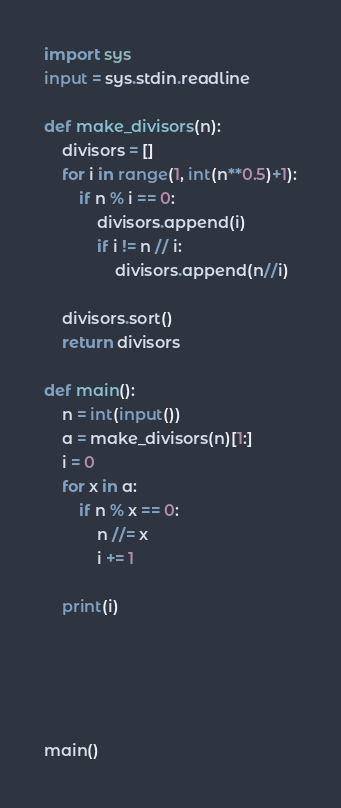<code> <loc_0><loc_0><loc_500><loc_500><_Python_>import sys
input = sys.stdin.readline

def make_divisors(n):
    divisors = []
    for i in range(1, int(n**0.5)+1):
        if n % i == 0:
            divisors.append(i)
            if i != n // i:
                divisors.append(n//i)

    divisors.sort()
    return divisors

def main():
    n = int(input())
    a = make_divisors(n)[1:]
    i = 0
    for x in a:
        if n % x == 0:
            n //= x
            i += 1

    print(i)





main()
</code> 